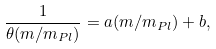Convert formula to latex. <formula><loc_0><loc_0><loc_500><loc_500>\frac { 1 } { \theta ( m / m _ { P l } ) } = a ( m / m _ { P l } ) + b ,</formula> 